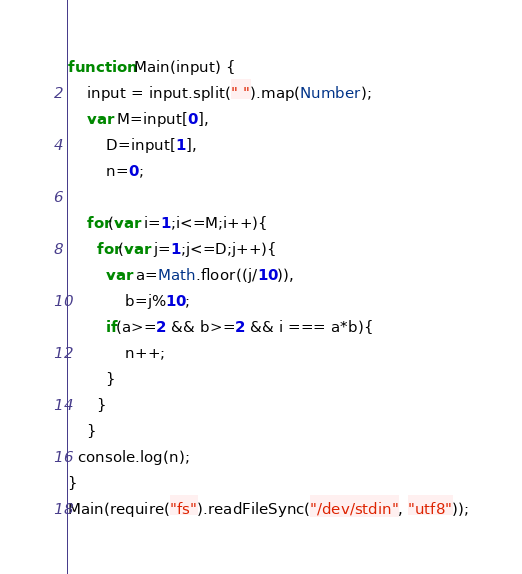<code> <loc_0><loc_0><loc_500><loc_500><_JavaScript_>function Main(input) {
    input = input.split(" ").map(Number);
  	var M=input[0], 
        D=input[1],
        n=0;
  
  	for(var i=1;i<=M;i++){
      for(var j=1;j<=D;j++){
        var a=Math.floor((j/10)),
            b=j%10;
        if(a>=2 && b>=2 && i === a*b){
        	n++;
        }
      }
    }
  console.log(n);
}
Main(require("fs").readFileSync("/dev/stdin", "utf8"));
</code> 